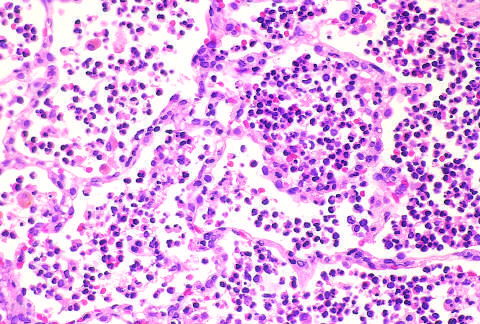do signals correspond to early red hepatization?
Answer the question using a single word or phrase. No 